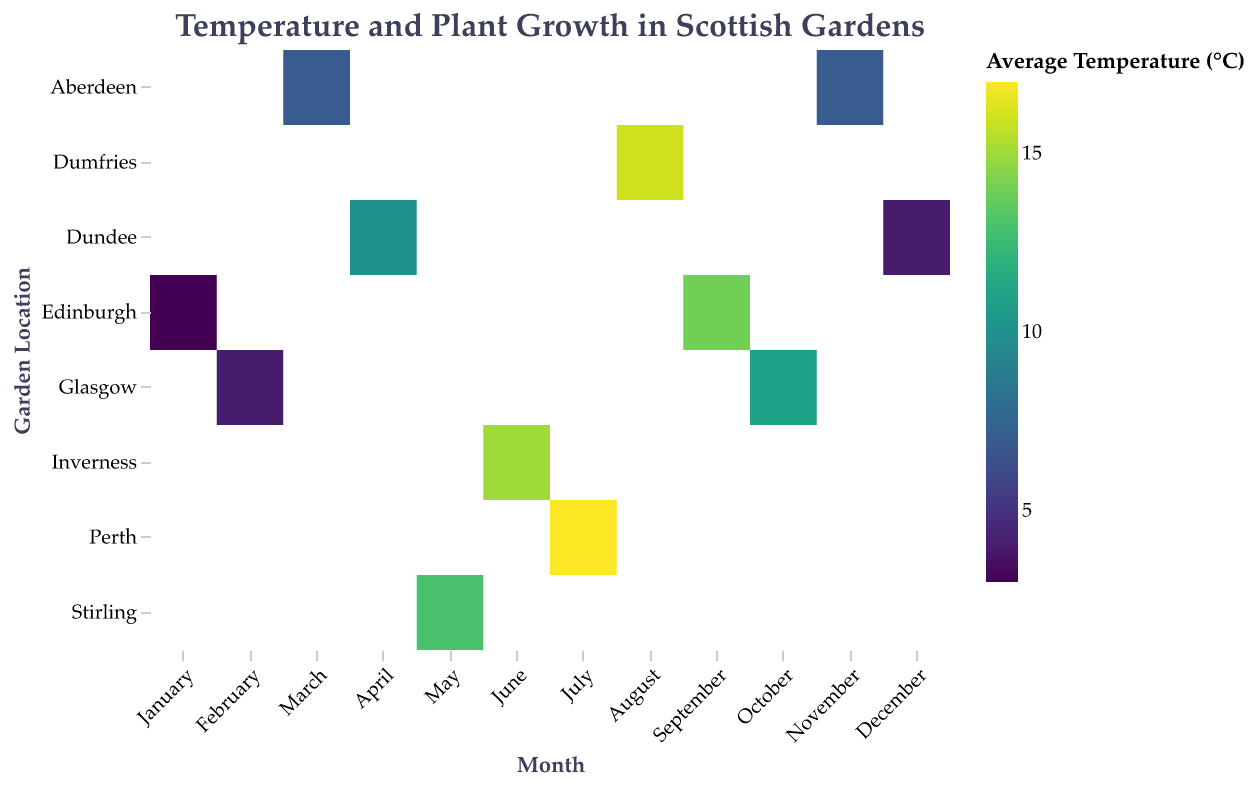What is the title of the heatmap? The title can be found at the top center of the heatmap. The title provides an overview of what the heatmap represents.
Answer: Temperature and Plant Growth in Scottish Gardens Which month and garden location combination shows the highest average temperature? To find the month and location with the highest average temperature, compare the color gradations in the heatmap. Darker colors represent higher temperatures.
Answer: July in Perth How does the plant growth impact in May compare to June? Look at the size of the rectangles for May and June. The larger the rectangle, the higher the plant growth impact.
Answer: May has a plant growth impact of 4 while June has a plant growth impact of 5 What is the average temperature in Edinburgh in September? Locate the intersection of Edinburgh and September in the heatmap and check the color and tooltip for the exact temperature value.
Answer: 14°C Which location shows the lowest average temperature in January? Find the column for January and identify the lightest shaded rectangle, which indicates the lowest temperature.
Answer: Edinburgh Which months have a plant growth impact of 3? Look for the rectangles with a size that corresponds to a plant growth impact of 3. Check the tooltips or size legend if needed.
Answer: April and October Compare the average temperatures in Aberdeen in March and November. How do they differ? Find the rectangles for March and November in Aberdeen. Check and compare their colors and tooltips to find the difference in temperature.
Answer: Both have an average temperature of 7°C, so there is no difference In which month and location does the plant growth impact reach its highest value? Look for the biggest rectangles in the heatmap, indicating the highest plant growth impact. The tooltip will confirm the exact value.
Answer: June in Inverness and July in Perth 